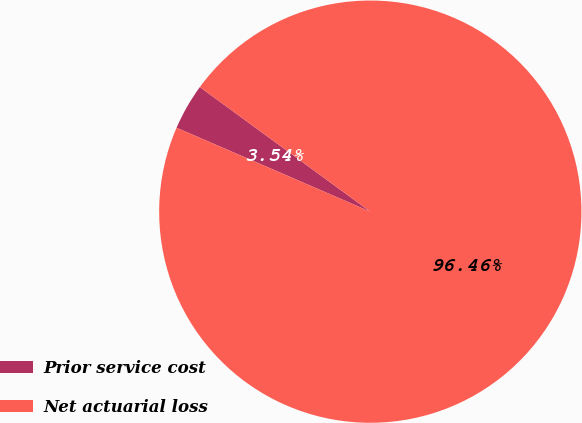Convert chart to OTSL. <chart><loc_0><loc_0><loc_500><loc_500><pie_chart><fcel>Prior service cost<fcel>Net actuarial loss<nl><fcel>3.54%<fcel>96.46%<nl></chart> 